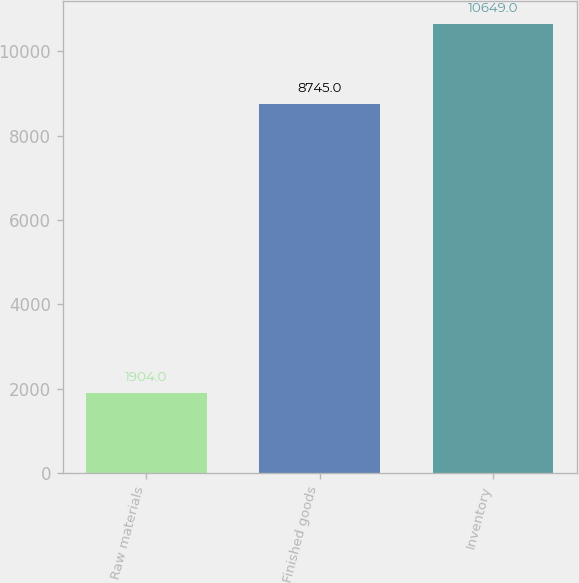Convert chart to OTSL. <chart><loc_0><loc_0><loc_500><loc_500><bar_chart><fcel>Raw materials<fcel>Finished goods<fcel>Inventory<nl><fcel>1904<fcel>8745<fcel>10649<nl></chart> 